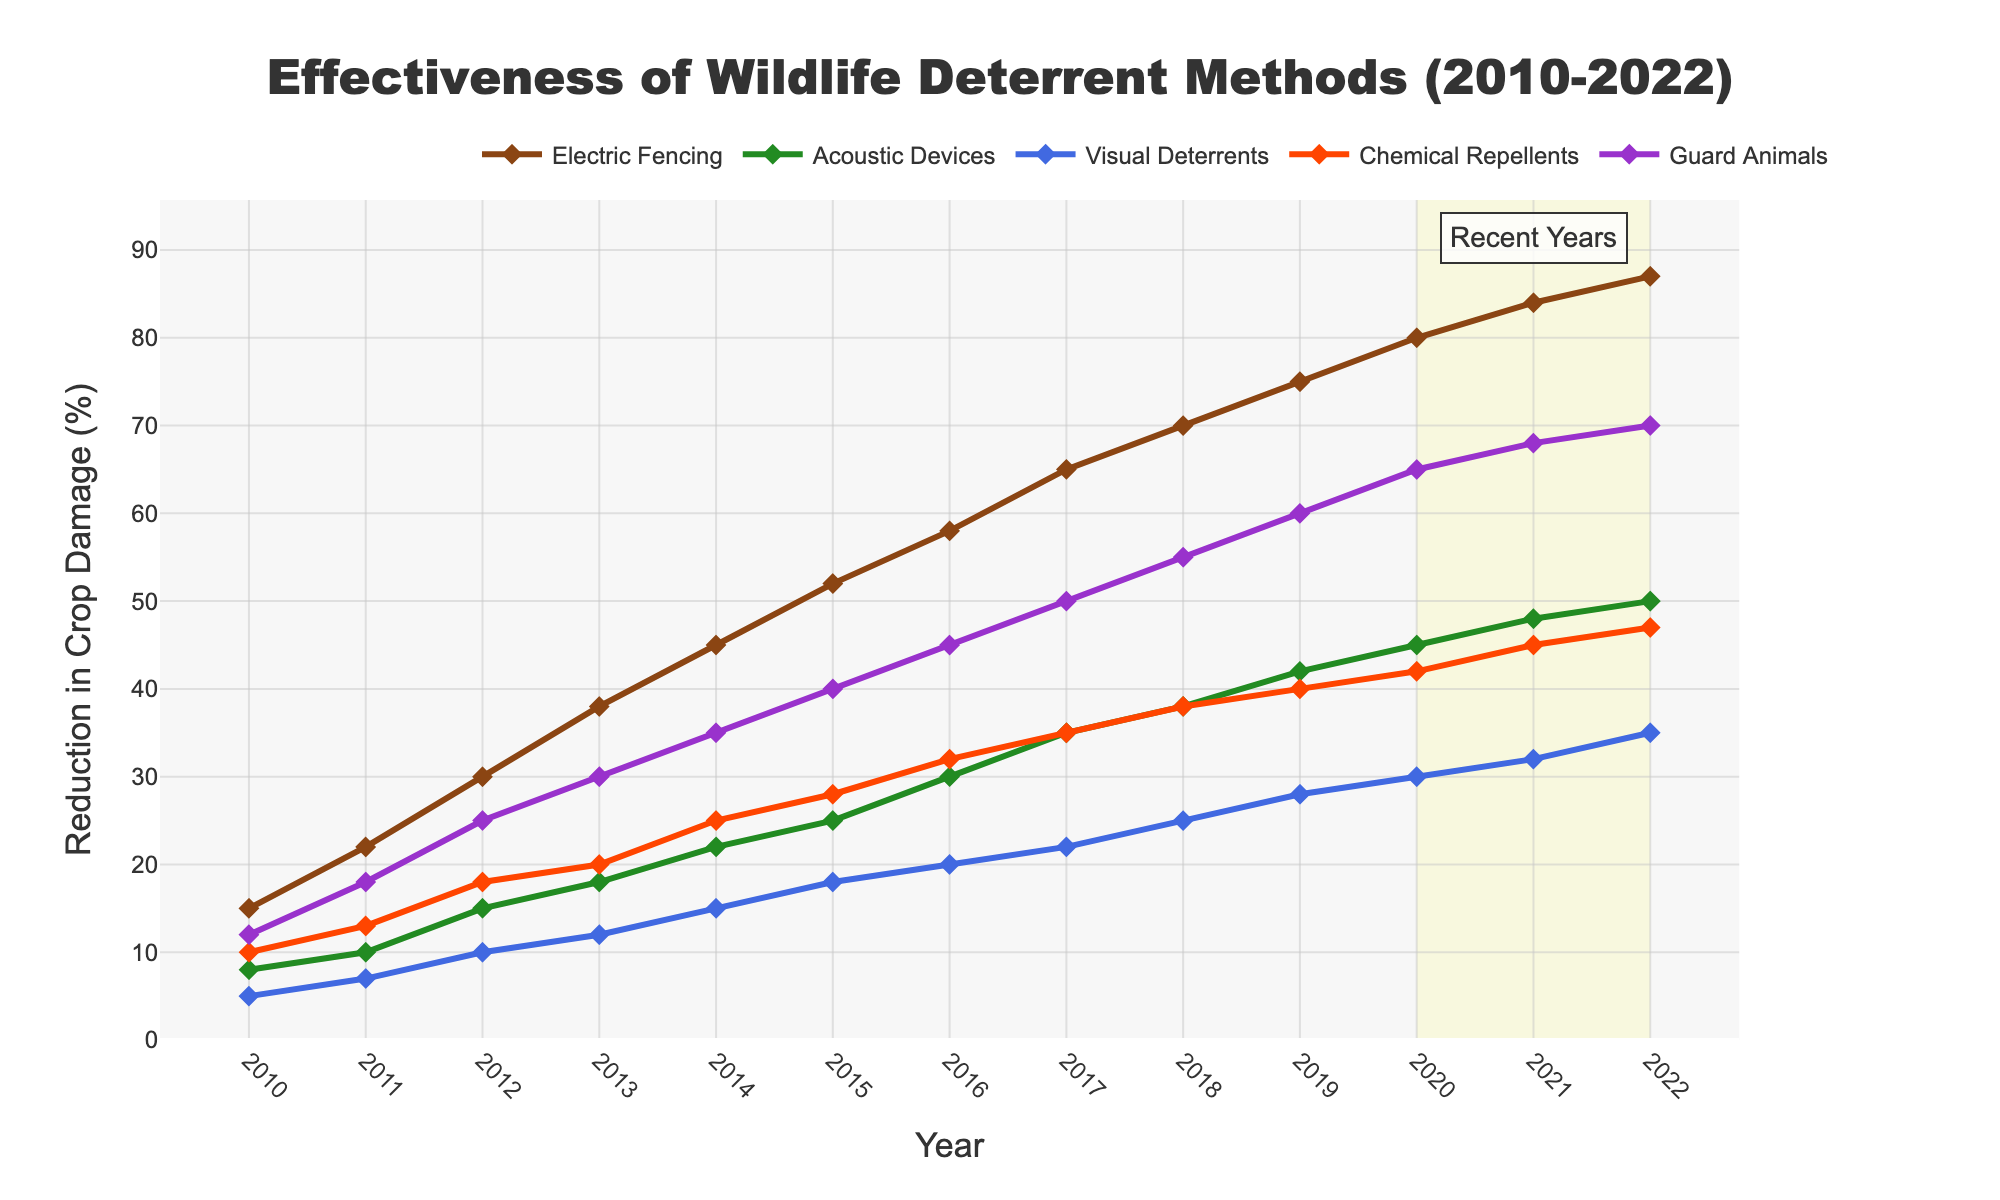What is the overall reduction in crop damage from Electric Fencing between 2010 and 2022? To find the overall reduction, look at the reduction in 2010 and 2022 and calculate the difference. In 2010, it is 15%, and in 2022 it is 87%. The overall reduction is 87% - 15% = 72%.
Answer: 72% Which wildlife deterrent method showed the smallest improvement in crop damage reduction from 2010 to 2022? Compare the reduction in 2010 and 2022 for each method and find the smallest difference: Electric Fencing (87% - 15% = 72%), Acoustic Devices (50% - 8% = 42%), Visual Deterrents (35% - 5% = 30%), Chemical Repellents (47% - 10% = 37%), Guard Animals (70% - 12% = 58%). Visual Deterrents show the smallest improvement.
Answer: Visual Deterrents In which year did Guard Animals surpass a 50% reduction in crop damage? Observe the data points for Guard Animals and identify the year when the reduction exceeded 50%. This first happens in 2017 with a reduction of 50%.
Answer: 2017 Which year saw the largest increase in reduction of crop damage for Acoustic Devices? Calculate the year-over-year increase and identify the largest: 
2011 (10% - 8% = 2%), 2012 (15% - 10% = 5%), 2013 (18% - 15% = 3%), 2014 (22% - 18% = 4%), 2015 (25% - 22% = 3%), 2016 (30% - 25% = 5%), 2017 (35% - 30% = 5%), 2018 (38% - 35% = 3%), 2019 (42% - 38% = 4%), 2020 (45% - 42% = 3%), 2021 (48% - 45% = 3%), 2022 (50% - 48% = 2%). The years 2012, 2016, and 2017 each saw the largest increase of 5%.
Answer: 2012, 2016, 2017 What is the average annual reduction in crop damage due to Chemical Repellents over the entire period? Sum the annual reductions and divide by the number of years: (10 + 13 + 18 + 20 + 25 + 28 + 32 + 35 + 38 + 40 + 42 + 45 + 47) / 13. The total is 393, so the average is 393 / 13 ≈ 30.2%.
Answer: 30.2% Which deterrent method was most effective in 2015? Look at the reduction percentages for each method in 2015 and identify the highest: Electric Fencing (52%), Acoustic Devices (25%), Visual Deterrents (18%), Chemical Repellents (28%), Guard Animals (40%). The most effective method was Electric Fencing.
Answer: Electric Fencing What is the trend in the reduction of crop damage caused by Visual Deterrents from 2010 to 2022? Observe the line representing Visual Deterrents from 2010 to 2022. The trend shows a consistent increase from 5% in 2010 to 35% in 2022.
Answer: Consistent increase Compare the effectiveness of Chemical Repellents and Acoustic Devices in 2019. Which one had a higher reduction in crop damage? Look at the reduction percentages for both methods in 2019: Chemical Repellents (40%) and Acoustic Devices (42%). Acoustic Devices had a higher reduction.
Answer: Acoustic Devices 